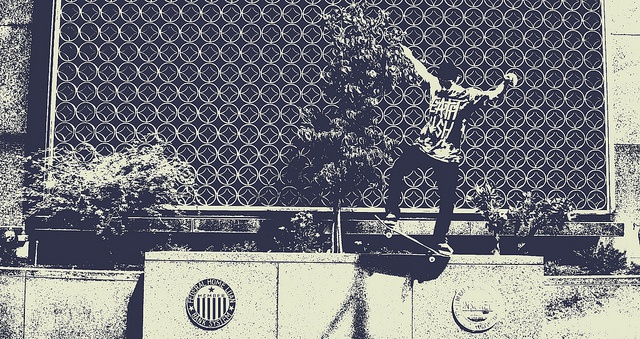Describe the objects in this image and their specific colors. I can see people in darkgray, black, beige, and gray tones and skateboard in darkgray, ivory, and black tones in this image. 